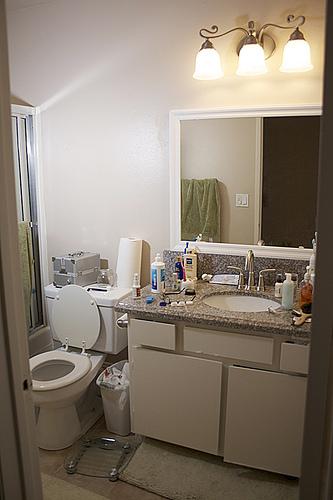Is this a layout for a magazine?
Keep it brief. No. Which decade do you believe this bathroom was built in?
Quick response, please. 70s. Is there a mirror in this photo?
Give a very brief answer. Yes. Does this bathroom look as it has been recently used and not cleaned up?
Short answer required. Yes. Is the green towel unused?
Short answer required. No. 